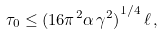Convert formula to latex. <formula><loc_0><loc_0><loc_500><loc_500>\tau _ { 0 } \leq { ( 1 6 \pi ^ { 2 } \alpha \, \gamma ^ { 2 } ) } ^ { 1 / 4 } \, \ell \, ,</formula> 